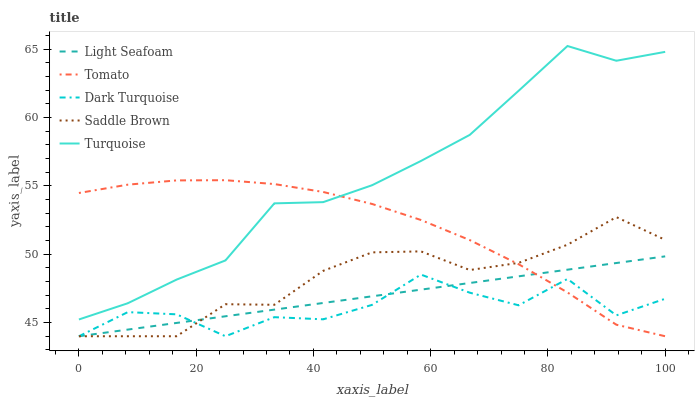Does Dark Turquoise have the minimum area under the curve?
Answer yes or no. Yes. Does Turquoise have the maximum area under the curve?
Answer yes or no. Yes. Does Turquoise have the minimum area under the curve?
Answer yes or no. No. Does Dark Turquoise have the maximum area under the curve?
Answer yes or no. No. Is Light Seafoam the smoothest?
Answer yes or no. Yes. Is Dark Turquoise the roughest?
Answer yes or no. Yes. Is Turquoise the smoothest?
Answer yes or no. No. Is Turquoise the roughest?
Answer yes or no. No. Does Tomato have the lowest value?
Answer yes or no. Yes. Does Turquoise have the lowest value?
Answer yes or no. No. Does Turquoise have the highest value?
Answer yes or no. Yes. Does Dark Turquoise have the highest value?
Answer yes or no. No. Is Saddle Brown less than Turquoise?
Answer yes or no. Yes. Is Turquoise greater than Saddle Brown?
Answer yes or no. Yes. Does Light Seafoam intersect Dark Turquoise?
Answer yes or no. Yes. Is Light Seafoam less than Dark Turquoise?
Answer yes or no. No. Is Light Seafoam greater than Dark Turquoise?
Answer yes or no. No. Does Saddle Brown intersect Turquoise?
Answer yes or no. No. 